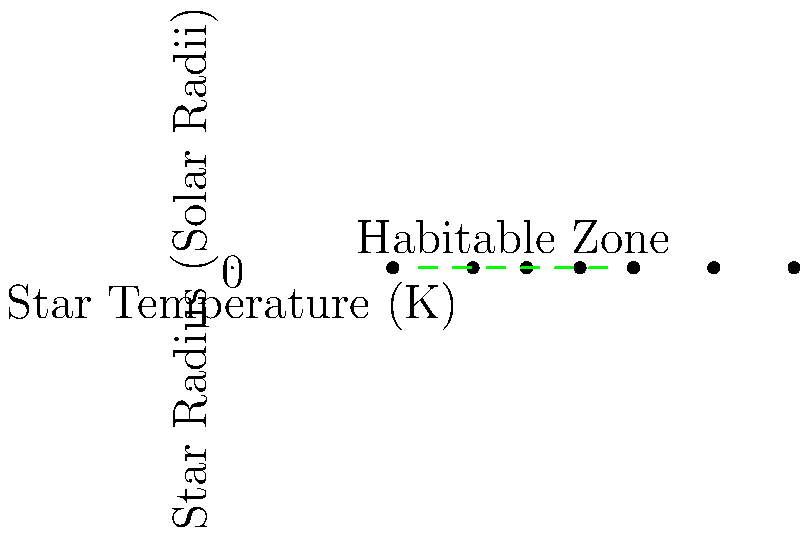Given the scatter plot of stellar data, which unconventional method could you employ to identify potential habitable exoplanets that might be overlooked by traditional search algorithms? To approach this challenge from an unconventional angle, we can consider the following steps:

1. Observe that the plot shows star temperature vs. star radius, with a rough "habitable zone" indicated.

2. Traditional methods focus on stars within this zone, typically G-type stars similar to our Sun (around 5500K, 1 solar radius).

3. An unconventional approach could involve looking for potential habitable planets around stars outside this zone:

   a) Consider smaller, cooler stars (M-dwarfs) below the habitable zone. These stars are often overlooked but could host habitable planets closer in.
   
   b) Examine larger, hotter stars above the zone. While not typically considered, they might have habitable moons around gas giants in their habitable zones.

4. We could develop an algorithm that:
   - Calculates the total energy output of each star using the Stefan-Boltzmann law: $L = 4\pi R^2 \sigma T^4$
   - Estimates the habitable zone distance for each star using $d = \sqrt{\frac{L}{L_{\text{Sun}}}}$
   - Considers stellar lifetimes and stability

5. Our algorithm could then flag stars with:
   - Stable long-term energy output
   - Potential for complex chemistry in their planetary systems
   - Lower stellar activity (for M-dwarfs)
   - Potential for large moons (for larger stars)

6. We could use machine learning to identify patterns in the data that human researchers might miss, potentially revealing new categories of habitable environments.

By thinking outside the conventional habitable zone box, we might discover potential life-supporting environments that traditional methods would overlook.
Answer: Develop an algorithm considering energy output, stellar stability, and potential for complex chemistry across all star types, using machine learning to identify overlooked habitable environments. 